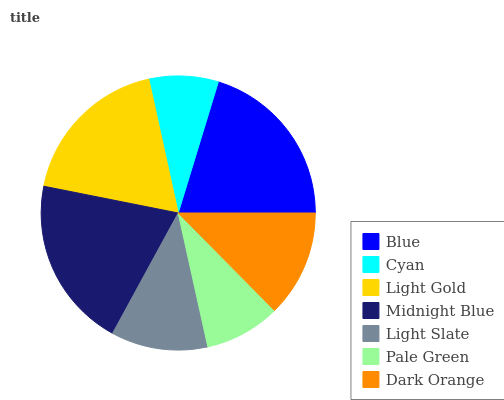Is Cyan the minimum?
Answer yes or no. Yes. Is Blue the maximum?
Answer yes or no. Yes. Is Light Gold the minimum?
Answer yes or no. No. Is Light Gold the maximum?
Answer yes or no. No. Is Light Gold greater than Cyan?
Answer yes or no. Yes. Is Cyan less than Light Gold?
Answer yes or no. Yes. Is Cyan greater than Light Gold?
Answer yes or no. No. Is Light Gold less than Cyan?
Answer yes or no. No. Is Dark Orange the high median?
Answer yes or no. Yes. Is Dark Orange the low median?
Answer yes or no. Yes. Is Blue the high median?
Answer yes or no. No. Is Light Slate the low median?
Answer yes or no. No. 